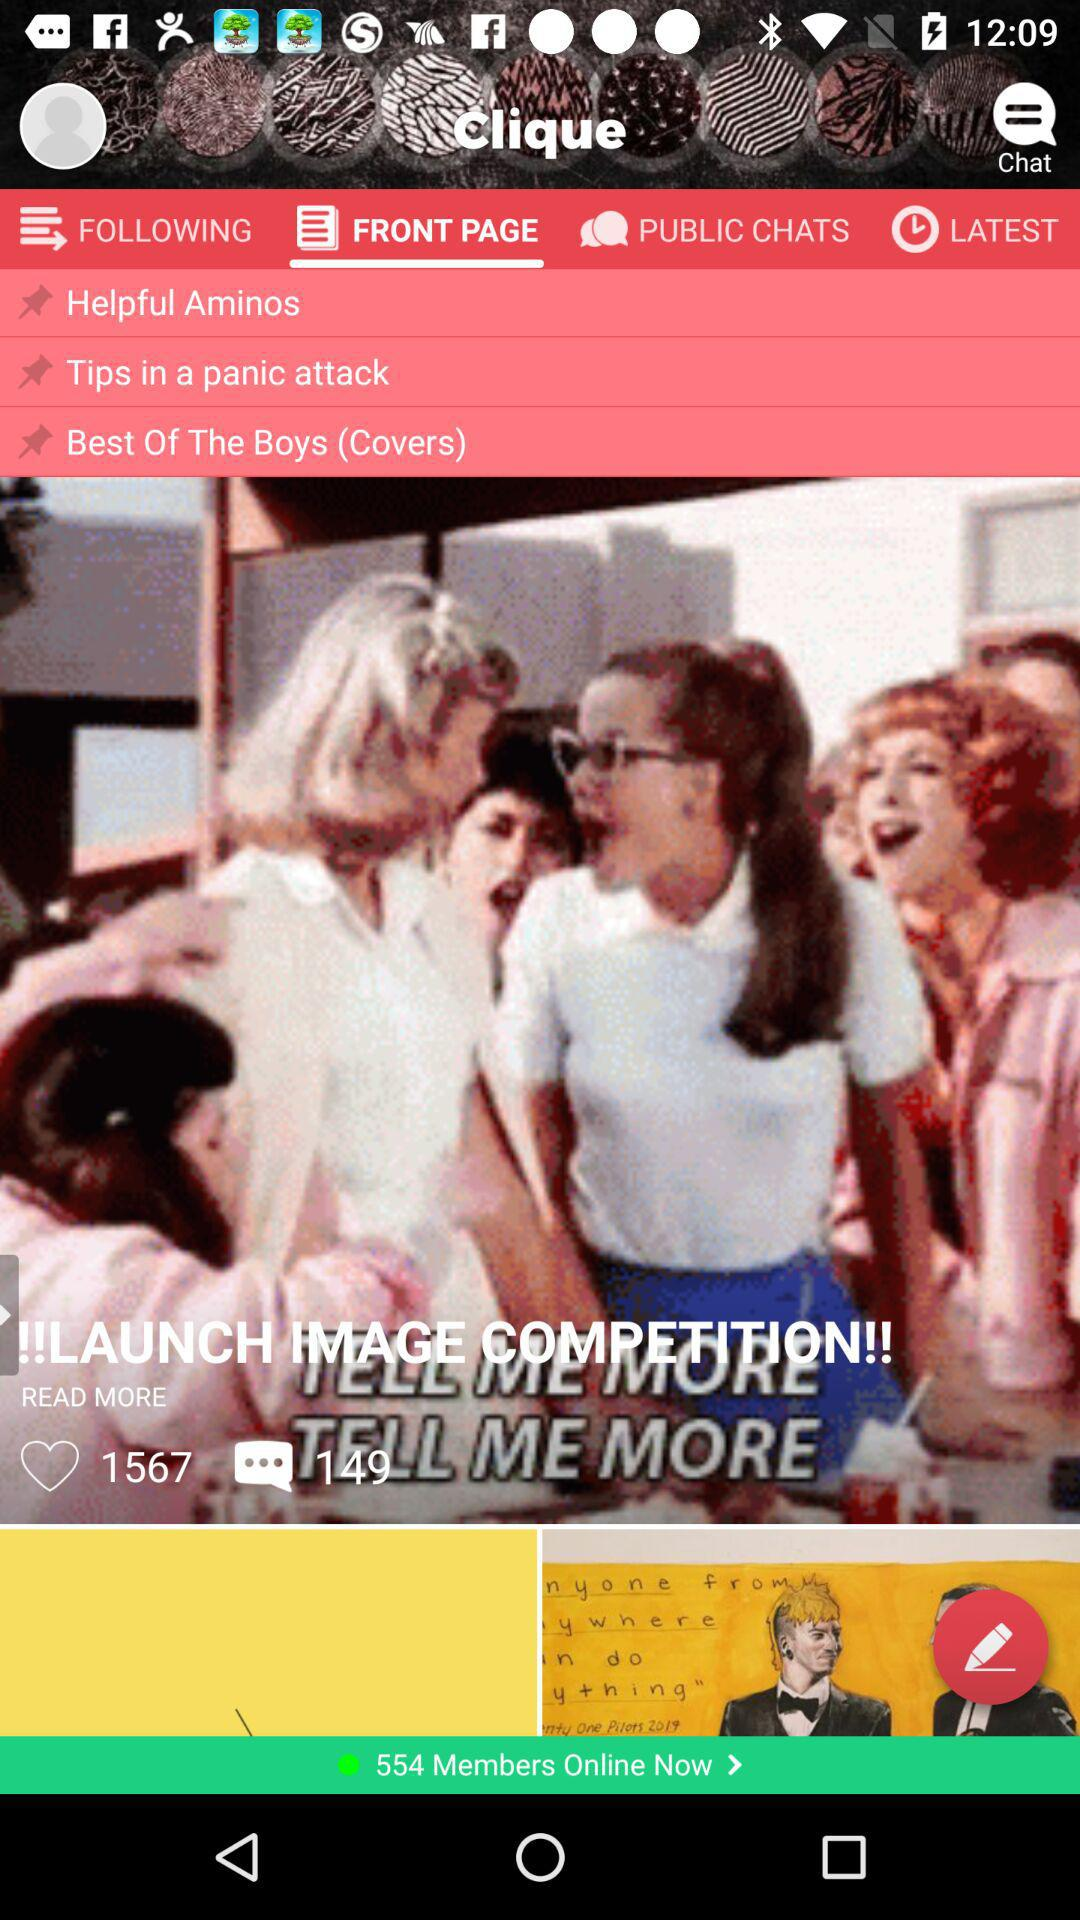How many comments are there? There are 149 comments. 